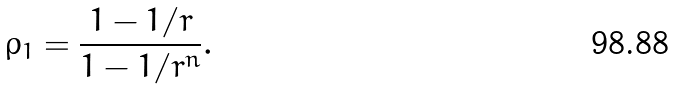<formula> <loc_0><loc_0><loc_500><loc_500>\rho _ { 1 } = \frac { 1 - 1 / r } { 1 - 1 / r ^ { n } } .</formula> 